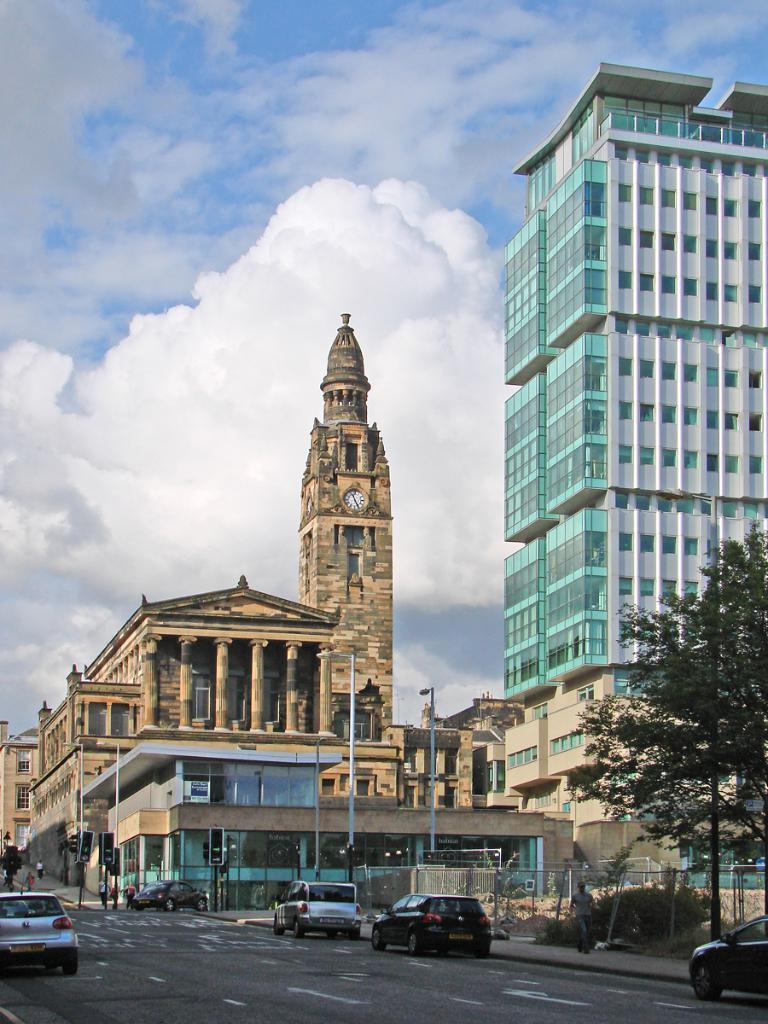What is the weather like in the image? The sky is cloudy in the image. What type of structures can be seen in the image? There are buildings and a clock tower in the image. What other objects are present in the image? There are poles, a tree, and vehicles in the image. Where are the vehicles located in the image? The vehicles are on the road in the image. What feature does the clock tower have? The clock tower has a clock in the image. What type of beast is sitting on the roof of the building in the image? There is no beast present on the roof of any building in the image. 